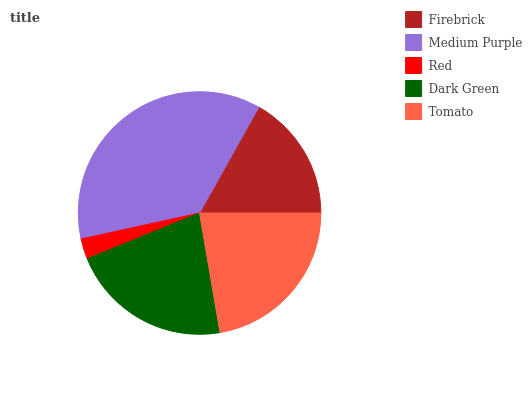Is Red the minimum?
Answer yes or no. Yes. Is Medium Purple the maximum?
Answer yes or no. Yes. Is Medium Purple the minimum?
Answer yes or no. No. Is Red the maximum?
Answer yes or no. No. Is Medium Purple greater than Red?
Answer yes or no. Yes. Is Red less than Medium Purple?
Answer yes or no. Yes. Is Red greater than Medium Purple?
Answer yes or no. No. Is Medium Purple less than Red?
Answer yes or no. No. Is Dark Green the high median?
Answer yes or no. Yes. Is Dark Green the low median?
Answer yes or no. Yes. Is Red the high median?
Answer yes or no. No. Is Tomato the low median?
Answer yes or no. No. 